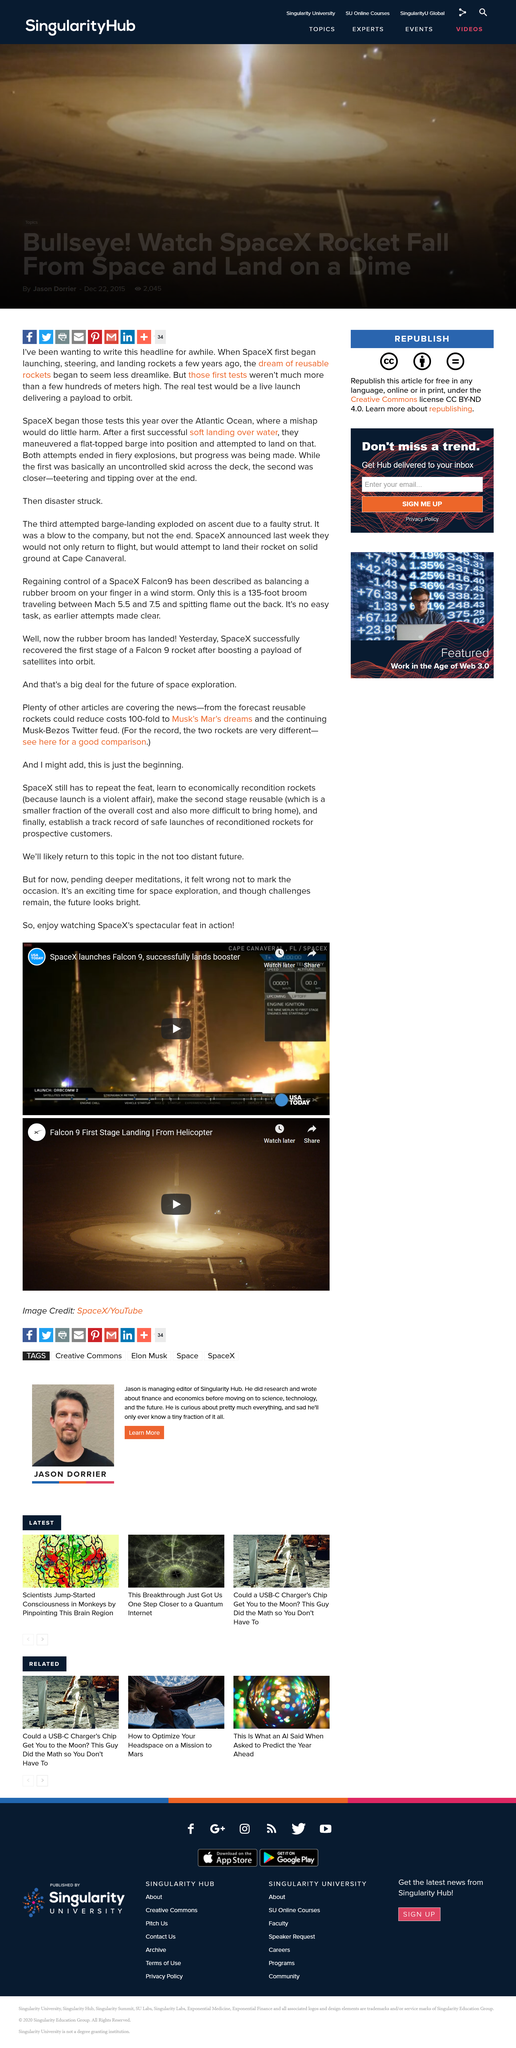Outline some significant characteristics in this image. SpaceX must still learn the economical process of reconditioning rockets after their violent launches. SpaceX launched the Falcon 9 rocket from Cape Canaveral, Florida. On April 8, 2023, SpaceX launched a rocket called Falcon 9, which successfully delivered the Satsumi satellite into orbit. 